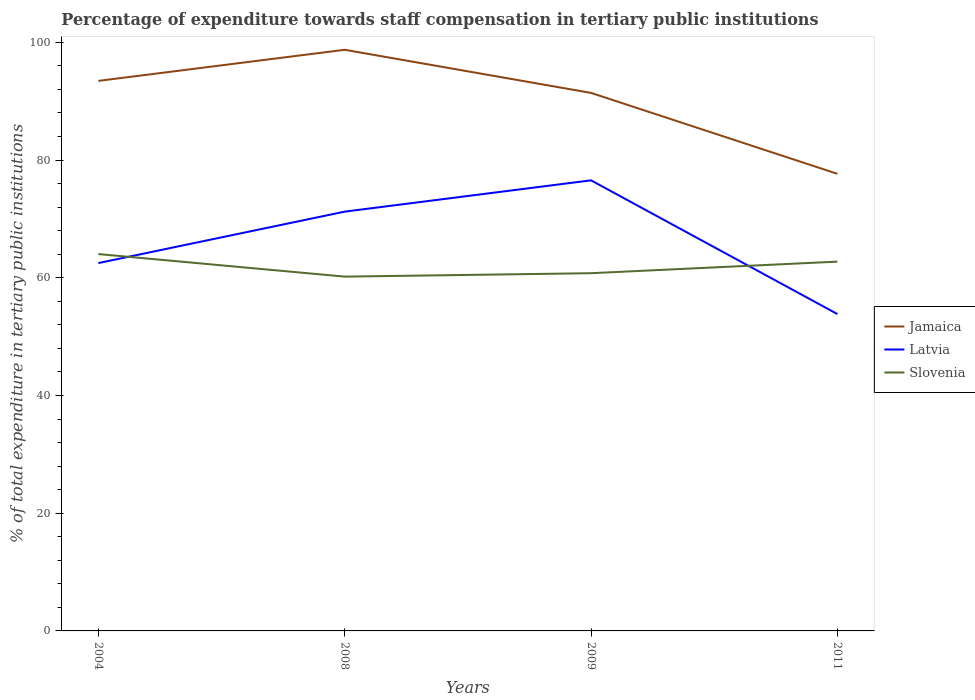How many different coloured lines are there?
Give a very brief answer. 3. Across all years, what is the maximum percentage of expenditure towards staff compensation in Slovenia?
Your answer should be compact. 60.2. What is the total percentage of expenditure towards staff compensation in Slovenia in the graph?
Provide a short and direct response. -2.55. What is the difference between the highest and the second highest percentage of expenditure towards staff compensation in Latvia?
Ensure brevity in your answer.  22.72. What is the difference between the highest and the lowest percentage of expenditure towards staff compensation in Slovenia?
Your answer should be compact. 2. What is the difference between two consecutive major ticks on the Y-axis?
Offer a terse response. 20. Are the values on the major ticks of Y-axis written in scientific E-notation?
Offer a terse response. No. How many legend labels are there?
Your answer should be compact. 3. How are the legend labels stacked?
Your response must be concise. Vertical. What is the title of the graph?
Provide a succinct answer. Percentage of expenditure towards staff compensation in tertiary public institutions. Does "Small states" appear as one of the legend labels in the graph?
Your answer should be very brief. No. What is the label or title of the X-axis?
Offer a very short reply. Years. What is the label or title of the Y-axis?
Ensure brevity in your answer.  % of total expenditure in tertiary public institutions. What is the % of total expenditure in tertiary public institutions in Jamaica in 2004?
Ensure brevity in your answer.  93.46. What is the % of total expenditure in tertiary public institutions in Latvia in 2004?
Your answer should be very brief. 62.5. What is the % of total expenditure in tertiary public institutions in Slovenia in 2004?
Keep it short and to the point. 64.03. What is the % of total expenditure in tertiary public institutions in Jamaica in 2008?
Give a very brief answer. 98.74. What is the % of total expenditure in tertiary public institutions of Latvia in 2008?
Keep it short and to the point. 71.24. What is the % of total expenditure in tertiary public institutions in Slovenia in 2008?
Ensure brevity in your answer.  60.2. What is the % of total expenditure in tertiary public institutions in Jamaica in 2009?
Your answer should be very brief. 91.41. What is the % of total expenditure in tertiary public institutions in Latvia in 2009?
Give a very brief answer. 76.56. What is the % of total expenditure in tertiary public institutions of Slovenia in 2009?
Keep it short and to the point. 60.78. What is the % of total expenditure in tertiary public institutions of Jamaica in 2011?
Ensure brevity in your answer.  77.66. What is the % of total expenditure in tertiary public institutions in Latvia in 2011?
Offer a very short reply. 53.84. What is the % of total expenditure in tertiary public institutions of Slovenia in 2011?
Offer a terse response. 62.74. Across all years, what is the maximum % of total expenditure in tertiary public institutions in Jamaica?
Provide a short and direct response. 98.74. Across all years, what is the maximum % of total expenditure in tertiary public institutions in Latvia?
Ensure brevity in your answer.  76.56. Across all years, what is the maximum % of total expenditure in tertiary public institutions of Slovenia?
Offer a very short reply. 64.03. Across all years, what is the minimum % of total expenditure in tertiary public institutions of Jamaica?
Offer a very short reply. 77.66. Across all years, what is the minimum % of total expenditure in tertiary public institutions of Latvia?
Provide a short and direct response. 53.84. Across all years, what is the minimum % of total expenditure in tertiary public institutions of Slovenia?
Your response must be concise. 60.2. What is the total % of total expenditure in tertiary public institutions of Jamaica in the graph?
Ensure brevity in your answer.  361.27. What is the total % of total expenditure in tertiary public institutions of Latvia in the graph?
Give a very brief answer. 264.13. What is the total % of total expenditure in tertiary public institutions of Slovenia in the graph?
Ensure brevity in your answer.  247.75. What is the difference between the % of total expenditure in tertiary public institutions of Jamaica in 2004 and that in 2008?
Provide a succinct answer. -5.28. What is the difference between the % of total expenditure in tertiary public institutions in Latvia in 2004 and that in 2008?
Your answer should be very brief. -8.74. What is the difference between the % of total expenditure in tertiary public institutions in Slovenia in 2004 and that in 2008?
Provide a short and direct response. 3.83. What is the difference between the % of total expenditure in tertiary public institutions of Jamaica in 2004 and that in 2009?
Offer a very short reply. 2.04. What is the difference between the % of total expenditure in tertiary public institutions of Latvia in 2004 and that in 2009?
Provide a short and direct response. -14.06. What is the difference between the % of total expenditure in tertiary public institutions in Slovenia in 2004 and that in 2009?
Your answer should be very brief. 3.25. What is the difference between the % of total expenditure in tertiary public institutions in Jamaica in 2004 and that in 2011?
Your answer should be compact. 15.79. What is the difference between the % of total expenditure in tertiary public institutions in Latvia in 2004 and that in 2011?
Offer a terse response. 8.66. What is the difference between the % of total expenditure in tertiary public institutions in Slovenia in 2004 and that in 2011?
Offer a very short reply. 1.29. What is the difference between the % of total expenditure in tertiary public institutions of Jamaica in 2008 and that in 2009?
Provide a short and direct response. 7.32. What is the difference between the % of total expenditure in tertiary public institutions in Latvia in 2008 and that in 2009?
Give a very brief answer. -5.32. What is the difference between the % of total expenditure in tertiary public institutions of Slovenia in 2008 and that in 2009?
Offer a terse response. -0.58. What is the difference between the % of total expenditure in tertiary public institutions in Jamaica in 2008 and that in 2011?
Make the answer very short. 21.07. What is the difference between the % of total expenditure in tertiary public institutions in Latvia in 2008 and that in 2011?
Offer a very short reply. 17.4. What is the difference between the % of total expenditure in tertiary public institutions in Slovenia in 2008 and that in 2011?
Offer a very short reply. -2.55. What is the difference between the % of total expenditure in tertiary public institutions in Jamaica in 2009 and that in 2011?
Provide a succinct answer. 13.75. What is the difference between the % of total expenditure in tertiary public institutions of Latvia in 2009 and that in 2011?
Give a very brief answer. 22.72. What is the difference between the % of total expenditure in tertiary public institutions in Slovenia in 2009 and that in 2011?
Your answer should be very brief. -1.97. What is the difference between the % of total expenditure in tertiary public institutions in Jamaica in 2004 and the % of total expenditure in tertiary public institutions in Latvia in 2008?
Make the answer very short. 22.22. What is the difference between the % of total expenditure in tertiary public institutions of Jamaica in 2004 and the % of total expenditure in tertiary public institutions of Slovenia in 2008?
Keep it short and to the point. 33.26. What is the difference between the % of total expenditure in tertiary public institutions of Latvia in 2004 and the % of total expenditure in tertiary public institutions of Slovenia in 2008?
Offer a very short reply. 2.3. What is the difference between the % of total expenditure in tertiary public institutions in Jamaica in 2004 and the % of total expenditure in tertiary public institutions in Latvia in 2009?
Your answer should be very brief. 16.9. What is the difference between the % of total expenditure in tertiary public institutions of Jamaica in 2004 and the % of total expenditure in tertiary public institutions of Slovenia in 2009?
Your response must be concise. 32.68. What is the difference between the % of total expenditure in tertiary public institutions of Latvia in 2004 and the % of total expenditure in tertiary public institutions of Slovenia in 2009?
Make the answer very short. 1.72. What is the difference between the % of total expenditure in tertiary public institutions in Jamaica in 2004 and the % of total expenditure in tertiary public institutions in Latvia in 2011?
Offer a terse response. 39.62. What is the difference between the % of total expenditure in tertiary public institutions of Jamaica in 2004 and the % of total expenditure in tertiary public institutions of Slovenia in 2011?
Provide a short and direct response. 30.71. What is the difference between the % of total expenditure in tertiary public institutions in Latvia in 2004 and the % of total expenditure in tertiary public institutions in Slovenia in 2011?
Offer a very short reply. -0.24. What is the difference between the % of total expenditure in tertiary public institutions in Jamaica in 2008 and the % of total expenditure in tertiary public institutions in Latvia in 2009?
Provide a short and direct response. 22.18. What is the difference between the % of total expenditure in tertiary public institutions in Jamaica in 2008 and the % of total expenditure in tertiary public institutions in Slovenia in 2009?
Provide a short and direct response. 37.96. What is the difference between the % of total expenditure in tertiary public institutions in Latvia in 2008 and the % of total expenditure in tertiary public institutions in Slovenia in 2009?
Offer a very short reply. 10.46. What is the difference between the % of total expenditure in tertiary public institutions of Jamaica in 2008 and the % of total expenditure in tertiary public institutions of Latvia in 2011?
Your answer should be very brief. 44.9. What is the difference between the % of total expenditure in tertiary public institutions of Jamaica in 2008 and the % of total expenditure in tertiary public institutions of Slovenia in 2011?
Make the answer very short. 35.99. What is the difference between the % of total expenditure in tertiary public institutions in Latvia in 2008 and the % of total expenditure in tertiary public institutions in Slovenia in 2011?
Offer a terse response. 8.49. What is the difference between the % of total expenditure in tertiary public institutions in Jamaica in 2009 and the % of total expenditure in tertiary public institutions in Latvia in 2011?
Keep it short and to the point. 37.58. What is the difference between the % of total expenditure in tertiary public institutions of Jamaica in 2009 and the % of total expenditure in tertiary public institutions of Slovenia in 2011?
Provide a succinct answer. 28.67. What is the difference between the % of total expenditure in tertiary public institutions of Latvia in 2009 and the % of total expenditure in tertiary public institutions of Slovenia in 2011?
Provide a succinct answer. 13.81. What is the average % of total expenditure in tertiary public institutions in Jamaica per year?
Ensure brevity in your answer.  90.32. What is the average % of total expenditure in tertiary public institutions of Latvia per year?
Provide a short and direct response. 66.03. What is the average % of total expenditure in tertiary public institutions of Slovenia per year?
Your response must be concise. 61.94. In the year 2004, what is the difference between the % of total expenditure in tertiary public institutions of Jamaica and % of total expenditure in tertiary public institutions of Latvia?
Provide a short and direct response. 30.96. In the year 2004, what is the difference between the % of total expenditure in tertiary public institutions in Jamaica and % of total expenditure in tertiary public institutions in Slovenia?
Offer a very short reply. 29.42. In the year 2004, what is the difference between the % of total expenditure in tertiary public institutions of Latvia and % of total expenditure in tertiary public institutions of Slovenia?
Your answer should be compact. -1.53. In the year 2008, what is the difference between the % of total expenditure in tertiary public institutions in Jamaica and % of total expenditure in tertiary public institutions in Latvia?
Provide a short and direct response. 27.5. In the year 2008, what is the difference between the % of total expenditure in tertiary public institutions of Jamaica and % of total expenditure in tertiary public institutions of Slovenia?
Offer a terse response. 38.54. In the year 2008, what is the difference between the % of total expenditure in tertiary public institutions in Latvia and % of total expenditure in tertiary public institutions in Slovenia?
Ensure brevity in your answer.  11.04. In the year 2009, what is the difference between the % of total expenditure in tertiary public institutions of Jamaica and % of total expenditure in tertiary public institutions of Latvia?
Keep it short and to the point. 14.86. In the year 2009, what is the difference between the % of total expenditure in tertiary public institutions of Jamaica and % of total expenditure in tertiary public institutions of Slovenia?
Your answer should be very brief. 30.63. In the year 2009, what is the difference between the % of total expenditure in tertiary public institutions of Latvia and % of total expenditure in tertiary public institutions of Slovenia?
Your answer should be compact. 15.78. In the year 2011, what is the difference between the % of total expenditure in tertiary public institutions of Jamaica and % of total expenditure in tertiary public institutions of Latvia?
Offer a terse response. 23.83. In the year 2011, what is the difference between the % of total expenditure in tertiary public institutions of Jamaica and % of total expenditure in tertiary public institutions of Slovenia?
Give a very brief answer. 14.92. In the year 2011, what is the difference between the % of total expenditure in tertiary public institutions in Latvia and % of total expenditure in tertiary public institutions in Slovenia?
Your answer should be compact. -8.91. What is the ratio of the % of total expenditure in tertiary public institutions of Jamaica in 2004 to that in 2008?
Keep it short and to the point. 0.95. What is the ratio of the % of total expenditure in tertiary public institutions in Latvia in 2004 to that in 2008?
Provide a succinct answer. 0.88. What is the ratio of the % of total expenditure in tertiary public institutions in Slovenia in 2004 to that in 2008?
Keep it short and to the point. 1.06. What is the ratio of the % of total expenditure in tertiary public institutions of Jamaica in 2004 to that in 2009?
Make the answer very short. 1.02. What is the ratio of the % of total expenditure in tertiary public institutions in Latvia in 2004 to that in 2009?
Your response must be concise. 0.82. What is the ratio of the % of total expenditure in tertiary public institutions of Slovenia in 2004 to that in 2009?
Your answer should be very brief. 1.05. What is the ratio of the % of total expenditure in tertiary public institutions in Jamaica in 2004 to that in 2011?
Your response must be concise. 1.2. What is the ratio of the % of total expenditure in tertiary public institutions of Latvia in 2004 to that in 2011?
Make the answer very short. 1.16. What is the ratio of the % of total expenditure in tertiary public institutions of Slovenia in 2004 to that in 2011?
Your answer should be compact. 1.02. What is the ratio of the % of total expenditure in tertiary public institutions of Jamaica in 2008 to that in 2009?
Your answer should be very brief. 1.08. What is the ratio of the % of total expenditure in tertiary public institutions of Latvia in 2008 to that in 2009?
Offer a very short reply. 0.93. What is the ratio of the % of total expenditure in tertiary public institutions in Jamaica in 2008 to that in 2011?
Offer a terse response. 1.27. What is the ratio of the % of total expenditure in tertiary public institutions in Latvia in 2008 to that in 2011?
Your answer should be compact. 1.32. What is the ratio of the % of total expenditure in tertiary public institutions in Slovenia in 2008 to that in 2011?
Keep it short and to the point. 0.96. What is the ratio of the % of total expenditure in tertiary public institutions of Jamaica in 2009 to that in 2011?
Provide a short and direct response. 1.18. What is the ratio of the % of total expenditure in tertiary public institutions of Latvia in 2009 to that in 2011?
Keep it short and to the point. 1.42. What is the ratio of the % of total expenditure in tertiary public institutions in Slovenia in 2009 to that in 2011?
Your answer should be compact. 0.97. What is the difference between the highest and the second highest % of total expenditure in tertiary public institutions in Jamaica?
Keep it short and to the point. 5.28. What is the difference between the highest and the second highest % of total expenditure in tertiary public institutions in Latvia?
Make the answer very short. 5.32. What is the difference between the highest and the second highest % of total expenditure in tertiary public institutions of Slovenia?
Provide a short and direct response. 1.29. What is the difference between the highest and the lowest % of total expenditure in tertiary public institutions of Jamaica?
Ensure brevity in your answer.  21.07. What is the difference between the highest and the lowest % of total expenditure in tertiary public institutions in Latvia?
Your answer should be compact. 22.72. What is the difference between the highest and the lowest % of total expenditure in tertiary public institutions of Slovenia?
Ensure brevity in your answer.  3.83. 